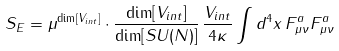<formula> <loc_0><loc_0><loc_500><loc_500>S _ { E } = \mu ^ { \dim [ V _ { i n t } ] } \cdot \frac { \dim [ V _ { i n t } ] } { \dim [ S U ( N ) ] } \, \frac { V _ { i n t } } { 4 \kappa } \int d ^ { 4 } x \, F ^ { a } _ { \mu \nu } F ^ { a } _ { \mu \nu }</formula> 